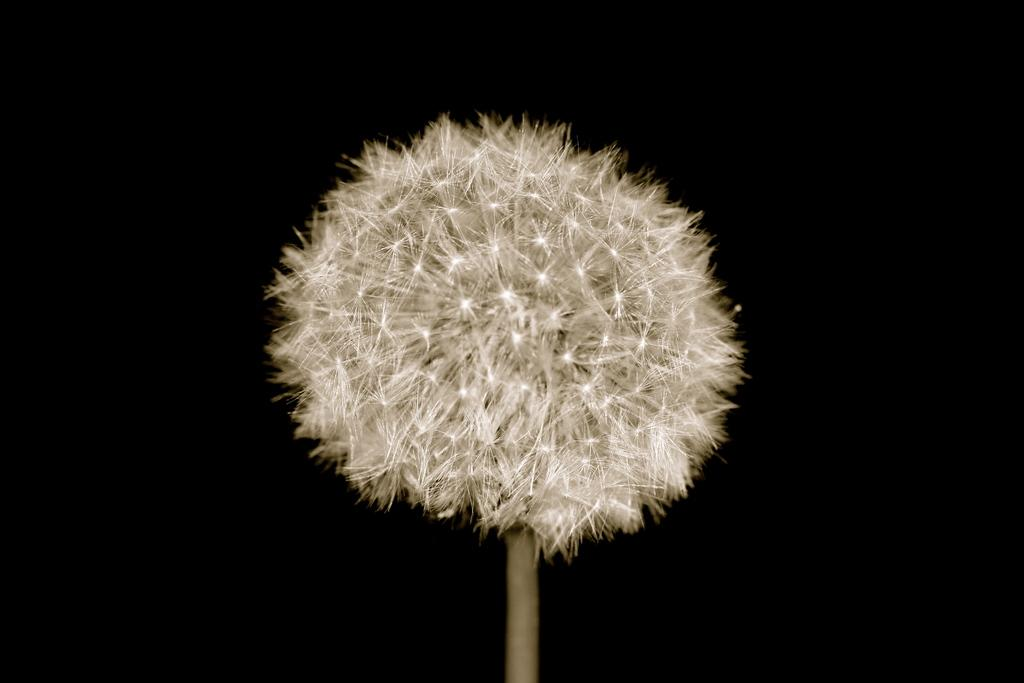What is the main subject of the picture? The main subject of the picture is a dandelion. Can you describe the dandelion in more detail? The dandelion is attached to a stem. What is the color of the backdrop in the image? The backdrop of the image is dark. How many rabbits can be seen playing with the dandelion in the image? There are no rabbits present in the image, and therefore no such activity can be observed. 